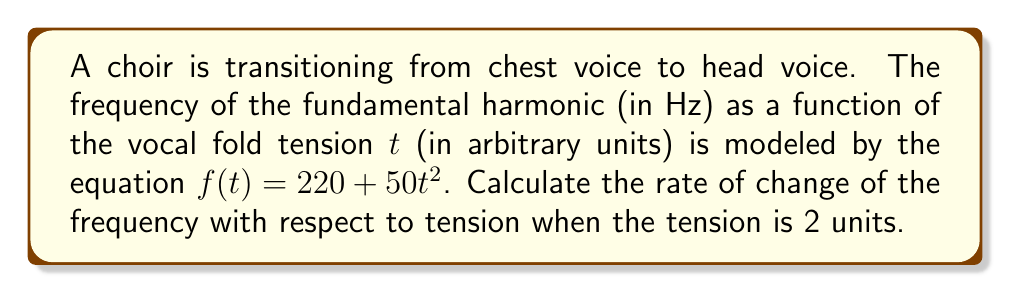Can you solve this math problem? To find the rate of change of frequency with respect to tension, we need to calculate the derivative of the given function $f(t)$ and then evaluate it at $t = 2$.

Step 1: Identify the function
$$f(t) = 220 + 50t^2$$

Step 2: Calculate the derivative
Using the power rule, we get:
$$f'(t) = 0 + 50 \cdot 2t = 100t$$

Step 3: Evaluate the derivative at $t = 2$
$$f'(2) = 100 \cdot 2 = 200$$

Therefore, when the tension is 2 units, the rate of change of frequency with respect to tension is 200 Hz per unit of tension.
Answer: $200$ Hz/unit 